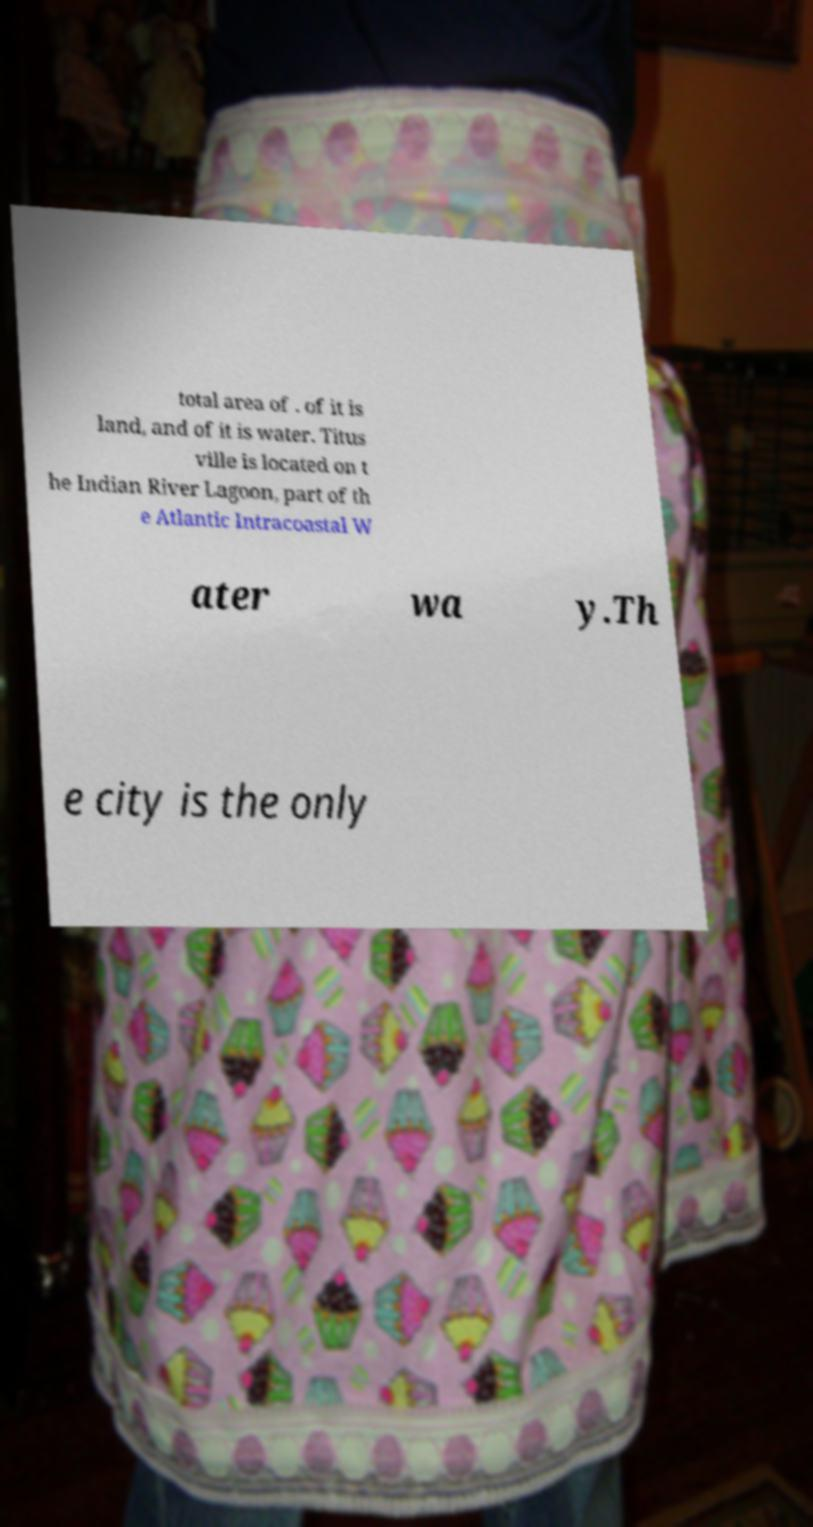Can you accurately transcribe the text from the provided image for me? total area of . of it is land, and of it is water. Titus ville is located on t he Indian River Lagoon, part of th e Atlantic Intracoastal W ater wa y.Th e city is the only 